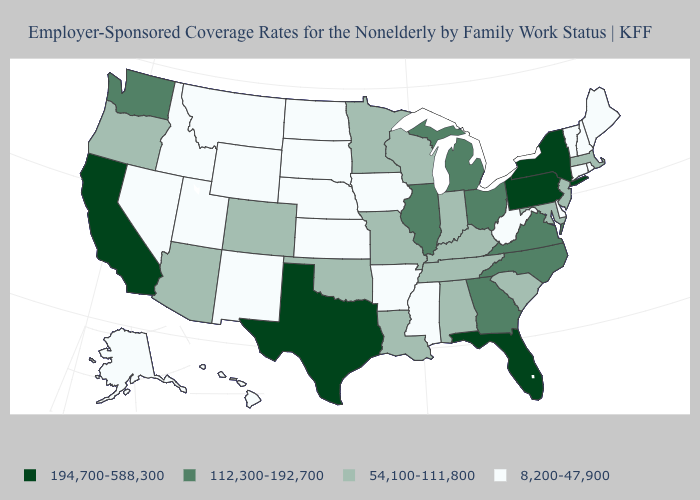Is the legend a continuous bar?
Give a very brief answer. No. What is the lowest value in the USA?
Answer briefly. 8,200-47,900. What is the lowest value in the USA?
Give a very brief answer. 8,200-47,900. How many symbols are there in the legend?
Concise answer only. 4. What is the lowest value in the USA?
Be succinct. 8,200-47,900. Is the legend a continuous bar?
Short answer required. No. Name the states that have a value in the range 112,300-192,700?
Short answer required. Georgia, Illinois, Michigan, North Carolina, Ohio, Virginia, Washington. Which states have the lowest value in the South?
Quick response, please. Arkansas, Delaware, Mississippi, West Virginia. What is the value of Minnesota?
Quick response, please. 54,100-111,800. Name the states that have a value in the range 54,100-111,800?
Quick response, please. Alabama, Arizona, Colorado, Indiana, Kentucky, Louisiana, Maryland, Massachusetts, Minnesota, Missouri, New Jersey, Oklahoma, Oregon, South Carolina, Tennessee, Wisconsin. What is the value of Connecticut?
Be succinct. 8,200-47,900. Does the map have missing data?
Give a very brief answer. No. What is the highest value in the USA?
Give a very brief answer. 194,700-588,300. Among the states that border New Jersey , does Delaware have the highest value?
Be succinct. No. Among the states that border Nevada , does Arizona have the highest value?
Keep it brief. No. 